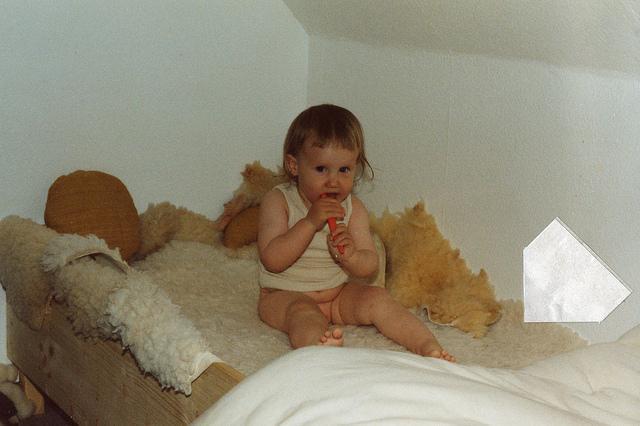How many children are there?
Give a very brief answer. 1. 